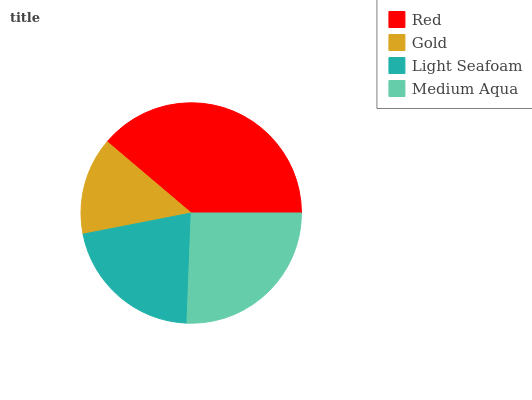Is Gold the minimum?
Answer yes or no. Yes. Is Red the maximum?
Answer yes or no. Yes. Is Light Seafoam the minimum?
Answer yes or no. No. Is Light Seafoam the maximum?
Answer yes or no. No. Is Light Seafoam greater than Gold?
Answer yes or no. Yes. Is Gold less than Light Seafoam?
Answer yes or no. Yes. Is Gold greater than Light Seafoam?
Answer yes or no. No. Is Light Seafoam less than Gold?
Answer yes or no. No. Is Medium Aqua the high median?
Answer yes or no. Yes. Is Light Seafoam the low median?
Answer yes or no. Yes. Is Light Seafoam the high median?
Answer yes or no. No. Is Medium Aqua the low median?
Answer yes or no. No. 